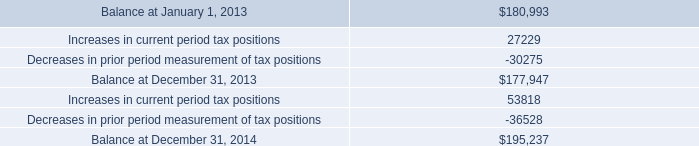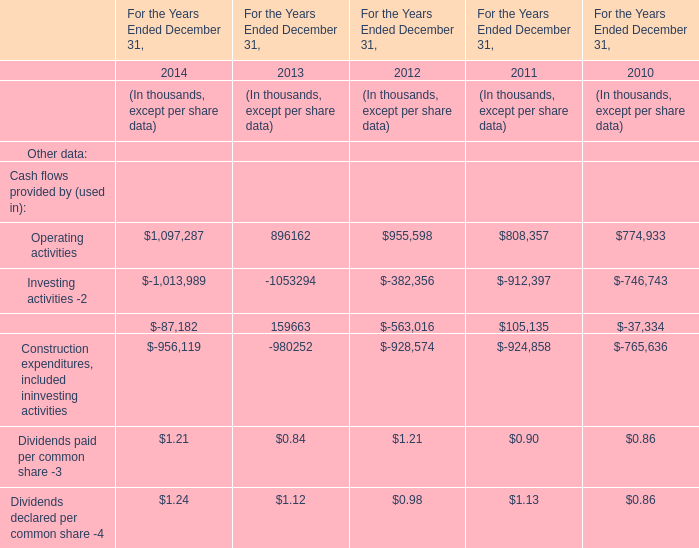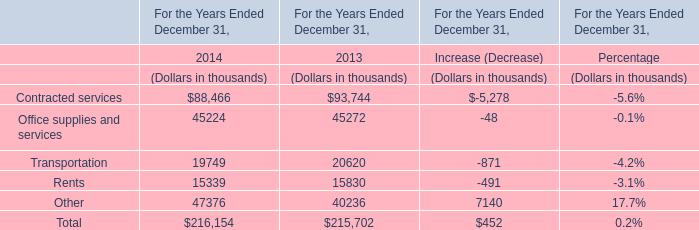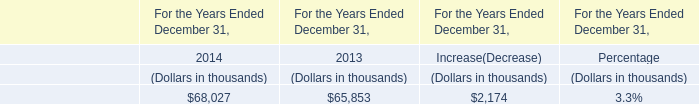what was canadian nol's as a percentage of state nol's in 2014? 
Computations: (6498 / 542705)
Answer: 0.01197. 